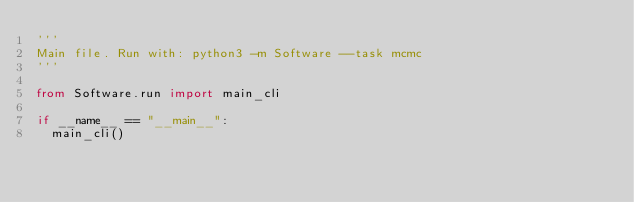Convert code to text. <code><loc_0><loc_0><loc_500><loc_500><_Python_>'''
Main file. Run with: python3 -m Software --task mcmc
'''

from Software.run import main_cli

if __name__ == "__main__":
  main_cli()</code> 